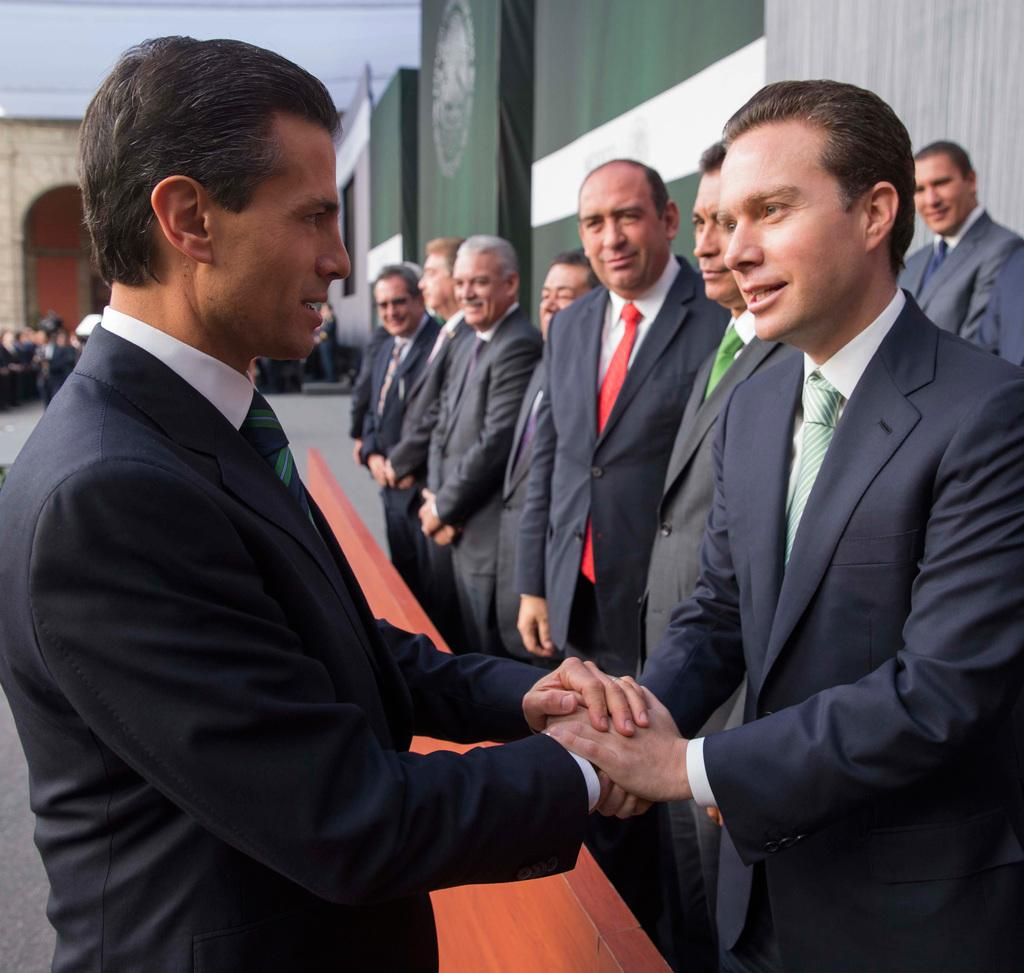What are the people in the image doing? The people in the image are standing and holding hands. What can be seen in the background of the image? There is a wall in the background of the image. What is the surface beneath the people's feet in the image? There is a floor visible in the image. What type of wrench is being used by the people in the image? There is no wrench present in the image; the people are holding hands. How many oranges are visible on the wall in the image? There are no oranges visible on the wall in the image; only a wall is present in the background. 